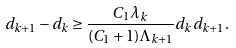<formula> <loc_0><loc_0><loc_500><loc_500>d _ { k + 1 } - d _ { k } \geq \frac { C _ { 1 } \lambda _ { k } } { ( C _ { 1 } + 1 ) \Lambda _ { k + 1 } } d _ { k } d _ { k + 1 } .</formula> 